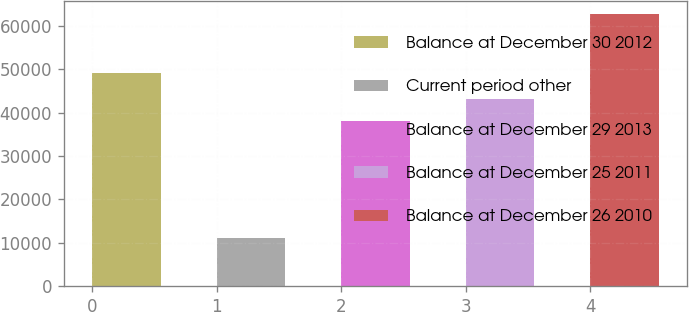Convert chart. <chart><loc_0><loc_0><loc_500><loc_500><bar_chart><fcel>Balance at December 30 2012<fcel>Current period other<fcel>Balance at December 29 2013<fcel>Balance at December 25 2011<fcel>Balance at December 26 2010<nl><fcel>49123<fcel>11104<fcel>38019<fcel>43172.8<fcel>62642<nl></chart> 